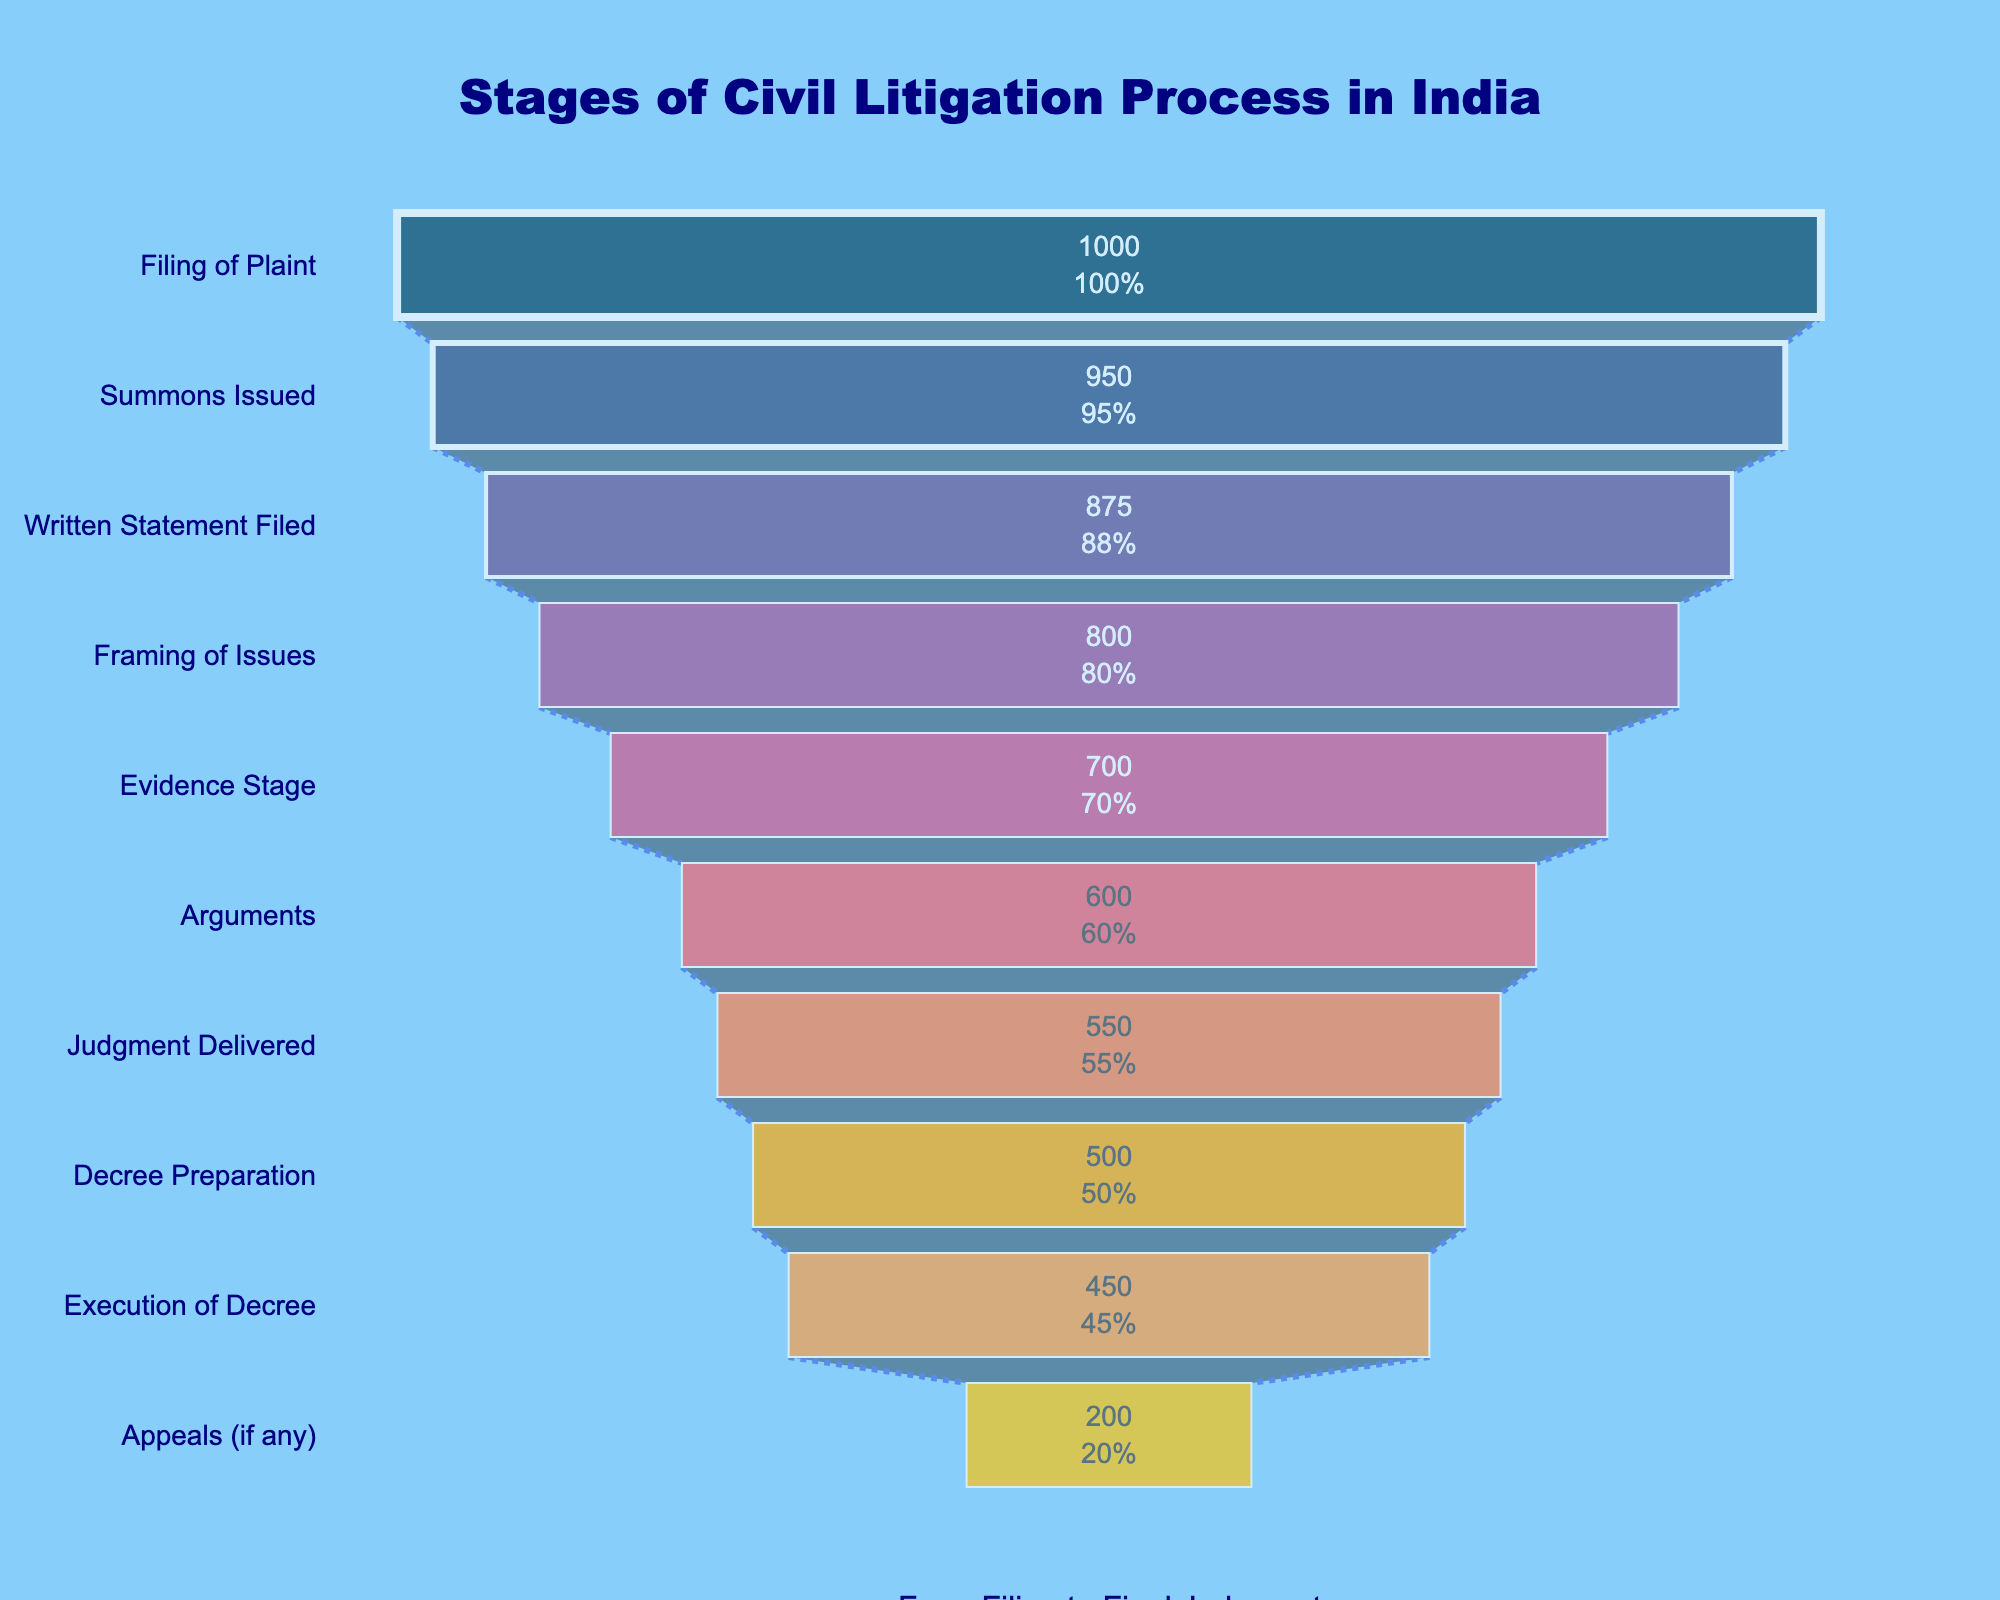What is the title of the funnel chart? The title is the text at the top of the chart that provides an overview of the chart's subject. Here, the title is clearly positioned and highlighted.
Answer: Stages of Civil Litigation Process in India Which stage has the highest number of cases? The highest number of cases will correspond to the largest segment at the top of the funnel chart.
Answer: Filing of Plaint How many cases reach the Evidence Stage? Look for the segment labeled "Evidence Stage" on the chart and note the number of cases inside that segment.
Answer: 700 What is the percentage of cases that go from Filing of Plaint to Summons Issued? Calculate the percentage by dividing the number of cases at the Summons Issued stage by the number from Filing of Plaint, and then multiply by 100. That visual information is provided in the chart.
Answer: 95% Which stage has the greatest drop-off in the number of cases from the previous stage? Find the two consecutive stages with the largest difference in the number of cases, by visually comparing segment sizes.
Answer: Appeals (if any) How many cases are lost between the Judgment Delivered and Decree Preparation stages? Subtract the number of cases at the Decree Preparation stage from the Judgment Delivered stage.
Answer: 50 What is the last stage in the funnel before the Appeals stage? Look at the funnel chart to identify the stage before Appeals.
Answer: Execution of Decree What percentage of cases are executed after decree preparation? Divide the number of cases in Execution of Decree by Decree Preparation, then multiply by 100.
Answer: 90% How many stages are there in the civil litigation process according to the funnel chart? Count the number of distinct segments in the chart.
Answer: 10 Which stages have fewer than 600 cases? Identify segments with numbers less than 600 by examining the chart.
Answer: Decree Preparation, Execution of Decree, Appeals (if any) 